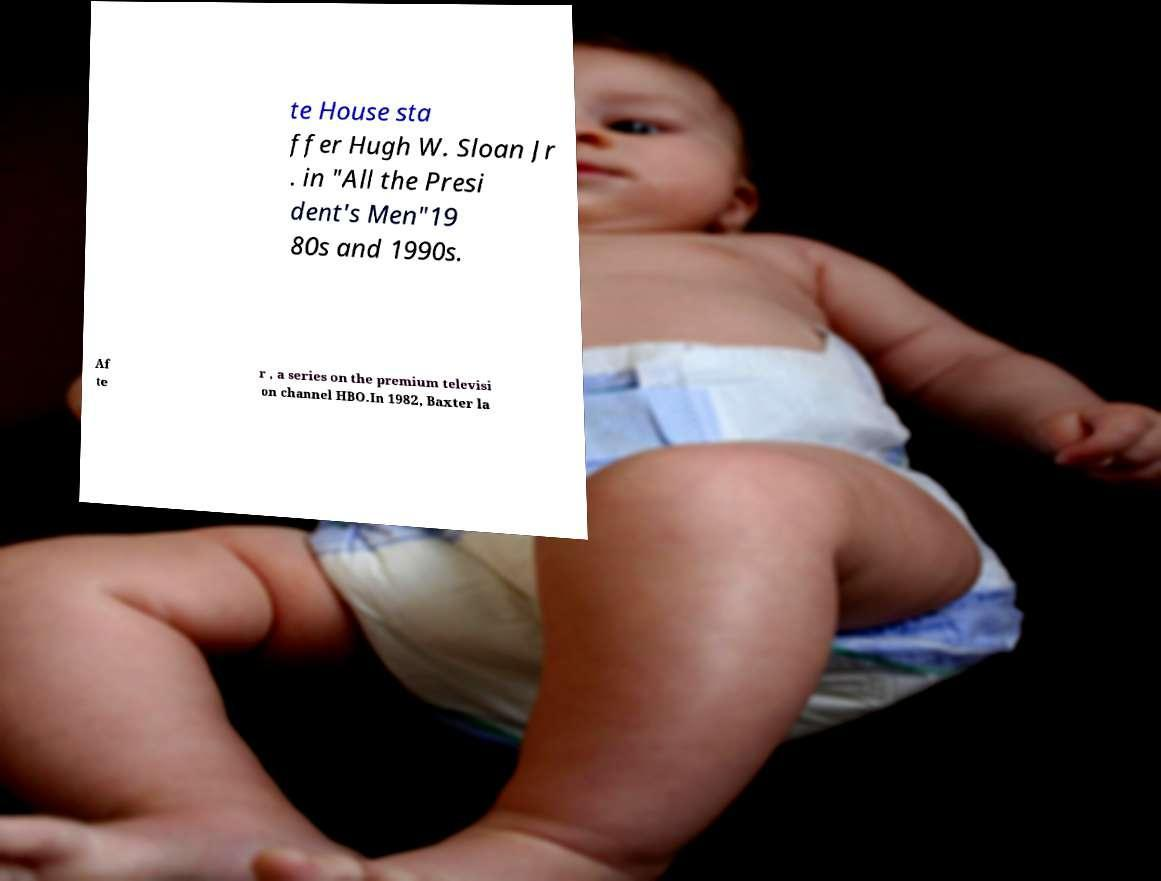I need the written content from this picture converted into text. Can you do that? te House sta ffer Hugh W. Sloan Jr . in "All the Presi dent's Men"19 80s and 1990s. Af te r , a series on the premium televisi on channel HBO.In 1982, Baxter la 